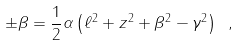<formula> <loc_0><loc_0><loc_500><loc_500>\pm \beta = \frac { 1 } { 2 } \alpha \left ( \ell ^ { 2 } + z ^ { 2 } + \beta ^ { 2 } - \gamma ^ { 2 } \right ) \ ,</formula> 